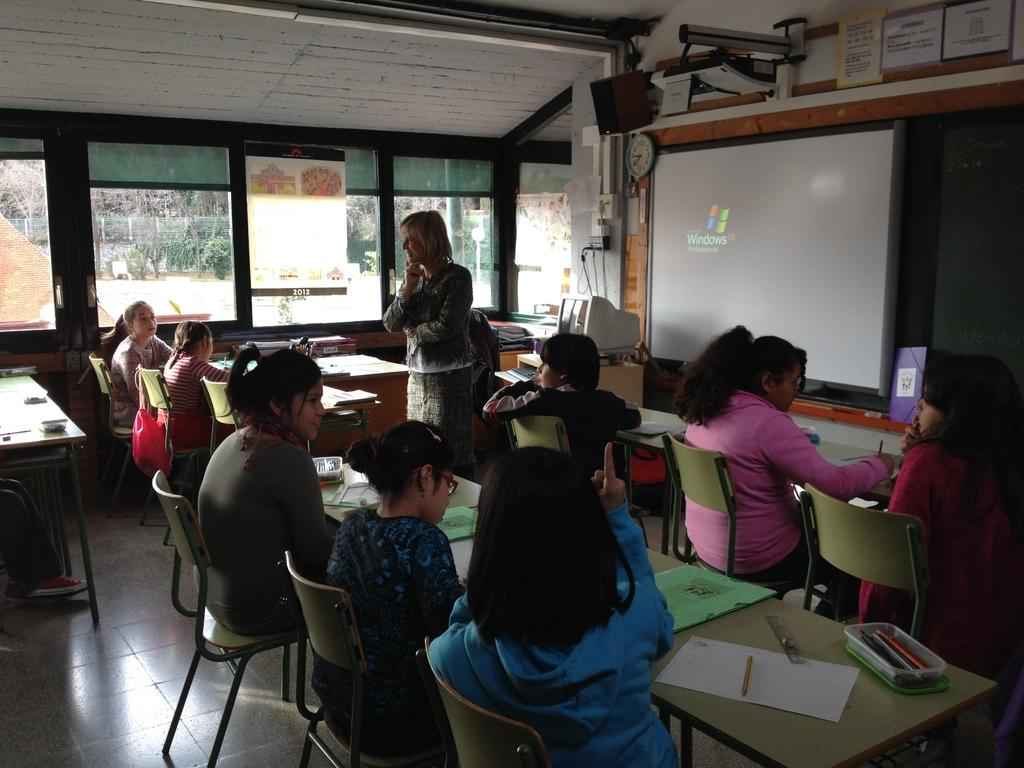What are the people in the image doing? The people in the image are sitting on chairs. What is the woman in the image doing? The woman is standing on a board in the image. What is the purpose of the board the woman is standing on? The purpose of the board is not clear from the image, but it could be for balance or support. What is the large, flat surface in the image? There is a projector screen in the image. What type of sand can be seen on the projector screen in the image? There is no sand present on the projector screen in the image. How does the rainstorm affect the people sitting on chairs in the image? There is no rainstorm present in the image; the people are sitting on chairs indoors. 